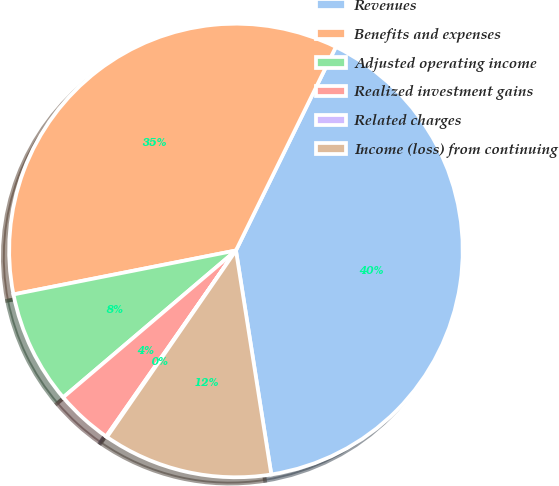<chart> <loc_0><loc_0><loc_500><loc_500><pie_chart><fcel>Revenues<fcel>Benefits and expenses<fcel>Adjusted operating income<fcel>Realized investment gains<fcel>Related charges<fcel>Income (loss) from continuing<nl><fcel>40.25%<fcel>35.37%<fcel>8.11%<fcel>4.09%<fcel>0.07%<fcel>12.12%<nl></chart> 